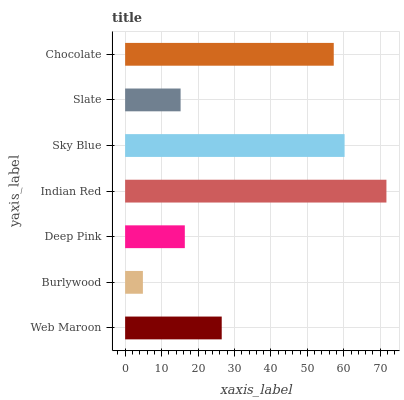Is Burlywood the minimum?
Answer yes or no. Yes. Is Indian Red the maximum?
Answer yes or no. Yes. Is Deep Pink the minimum?
Answer yes or no. No. Is Deep Pink the maximum?
Answer yes or no. No. Is Deep Pink greater than Burlywood?
Answer yes or no. Yes. Is Burlywood less than Deep Pink?
Answer yes or no. Yes. Is Burlywood greater than Deep Pink?
Answer yes or no. No. Is Deep Pink less than Burlywood?
Answer yes or no. No. Is Web Maroon the high median?
Answer yes or no. Yes. Is Web Maroon the low median?
Answer yes or no. Yes. Is Burlywood the high median?
Answer yes or no. No. Is Indian Red the low median?
Answer yes or no. No. 